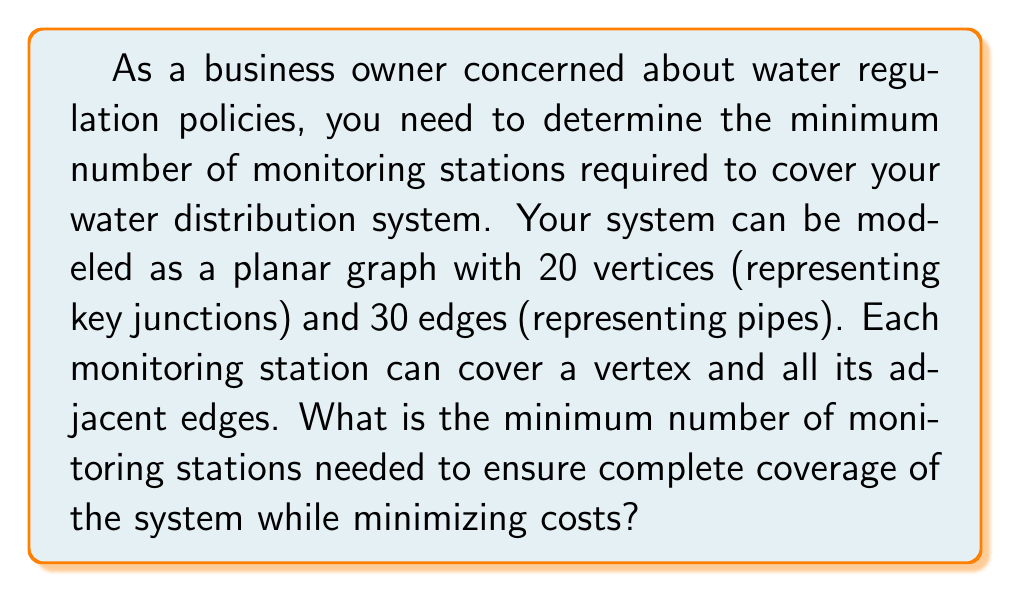Give your solution to this math problem. To solve this problem, we need to find the minimum dominating set of the graph representing the water distribution system. A dominating set is a subset of vertices such that every vertex in the graph is either in the set or adjacent to a vertex in the set.

Let's approach this step-by-step:

1) First, we need to consider the properties of the graph:
   - It's a planar graph with 20 vertices and 30 edges.
   - The average degree of a vertex is $\frac{2 \cdot 30}{20} = 3$.

2) For planar graphs, we can use the following theorem:
   Every planar graph has a dominating set of size at most $\frac{n}{4}$, where $n$ is the number of vertices.

3) In our case, $\frac{n}{4} = \frac{20}{4} = 5$.

4) However, this is an upper bound. We can potentially find a smaller dominating set.

5) Given the average degree of 3, we can estimate that each monitoring station might cover about 4 vertices on average (itself and 3 neighbors).

6) If each station covers 4 vertices, we would need approximately $\frac{20}{4} = 5$ stations.

7) However, due to the structure of the graph, some stations might cover more than 4 vertices, potentially reducing the number needed.

8) Without more specific information about the graph structure, we can conclude that the minimum number of monitoring stations needed is likely to be either 4 or 5.

9) Given the business owner's desire to minimize costs while ensuring complete coverage, we should choose the lower number that guarantees coverage.

Therefore, the minimum number of monitoring stations needed is likely 4, but it could be up to 5 in the worst case.
Answer: 4 monitoring stations 